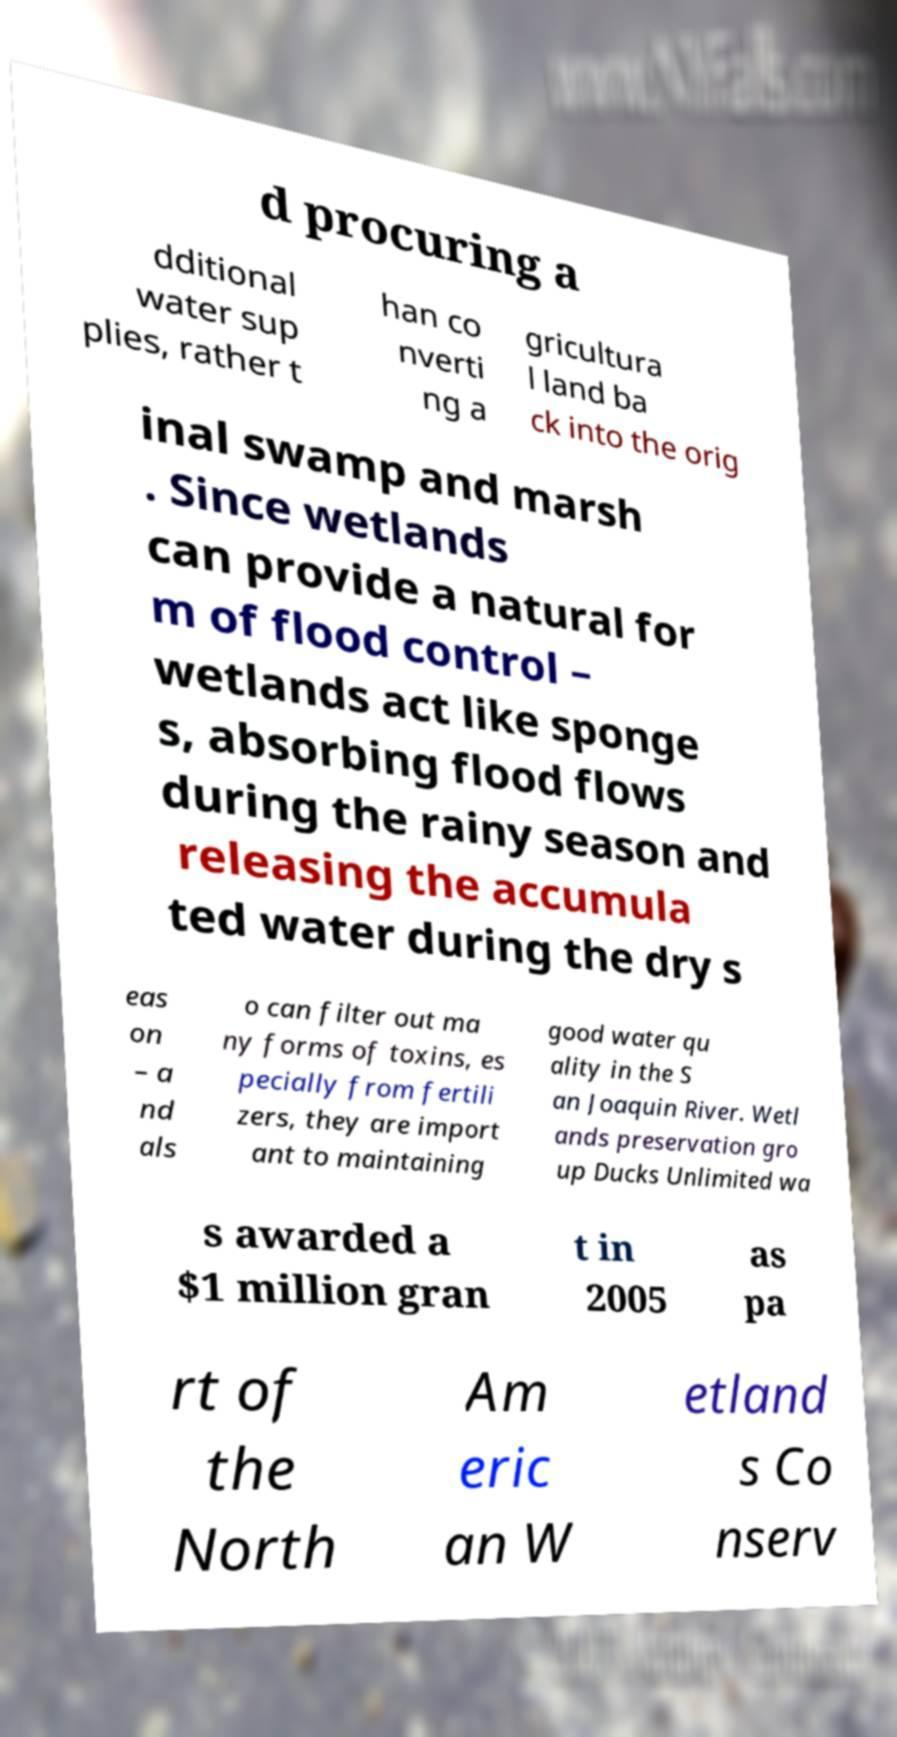Can you read and provide the text displayed in the image?This photo seems to have some interesting text. Can you extract and type it out for me? d procuring a dditional water sup plies, rather t han co nverti ng a gricultura l land ba ck into the orig inal swamp and marsh . Since wetlands can provide a natural for m of flood control – wetlands act like sponge s, absorbing flood flows during the rainy season and releasing the accumula ted water during the dry s eas on – a nd als o can filter out ma ny forms of toxins, es pecially from fertili zers, they are import ant to maintaining good water qu ality in the S an Joaquin River. Wetl ands preservation gro up Ducks Unlimited wa s awarded a $1 million gran t in 2005 as pa rt of the North Am eric an W etland s Co nserv 